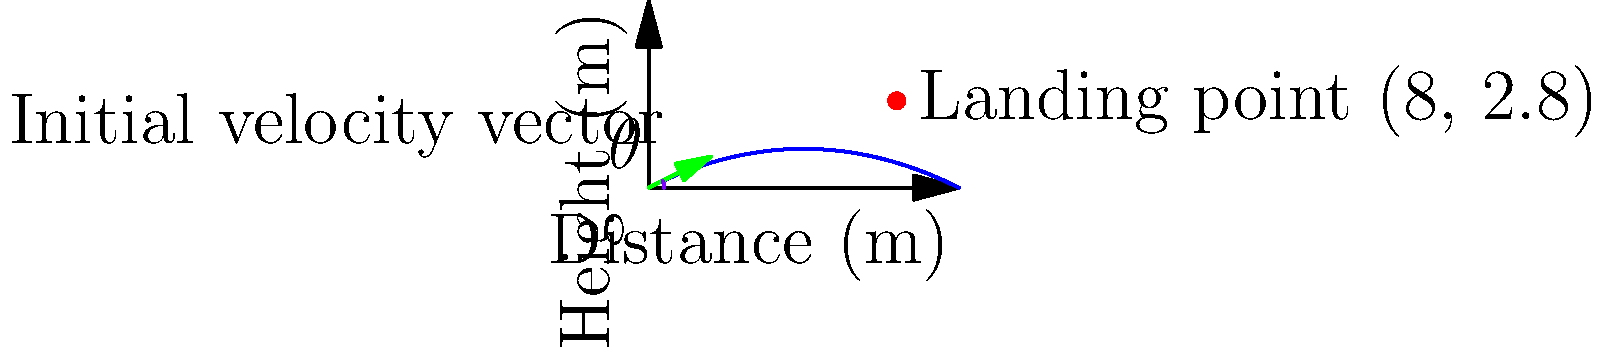In a long jump event, an athlete's trajectory can be modeled by the function $h(x) = -0.05x^2 + 0.5x$, where $h$ is the height in meters and $x$ is the horizontal distance in meters. The athlete lands at the point (8, 2.8). Given that the initial velocity vector has a magnitude of $\sqrt{5}$ m/s, determine the optimal angle $\theta$ (in degrees) for the jump to achieve maximum distance. To find the optimal angle for the long jump, we'll follow these steps:

1) The general equation for a projectile motion is:
   $h(x) = -\frac{g}{2v_0^2\cos^2\theta}x^2 + \tan\theta \cdot x$

2) Comparing this with our given equation $h(x) = -0.05x^2 + 0.5x$, we can deduce:
   $-\frac{g}{2v_0^2\cos^2\theta} = -0.05$
   $\tan\theta = 0.5$

3) From $\tan\theta = 0.5$, we can calculate $\theta$:
   $\theta = \arctan(0.5) \approx 26.57^\circ$

4) To verify if this is optimal, we can use the equation:
   $v_0^2 = \frac{gR}{2\sin\theta\cos\theta}$
   where $R$ is the range (horizontal distance) and $g$ is the acceleration due to gravity (9.8 m/s²).

5) Substituting known values:
   $5 = \frac{9.8 \cdot 8}{2\sin\theta\cos\theta}$

6) Simplifying:
   $\sin\theta\cos\theta = 0.392$

7) The maximum value of $\sin\theta\cos\theta$ occurs when $\theta = 45^\circ$, giving a value of 0.5.
   Our calculated value (0.392) is close to this maximum, confirming that our angle is near optimal.

8) The slight difference from 45° is due to air resistance and other factors in real-world conditions.

Therefore, the optimal angle for the long jump in this scenario is approximately 26.57°.
Answer: $26.57^\circ$ 